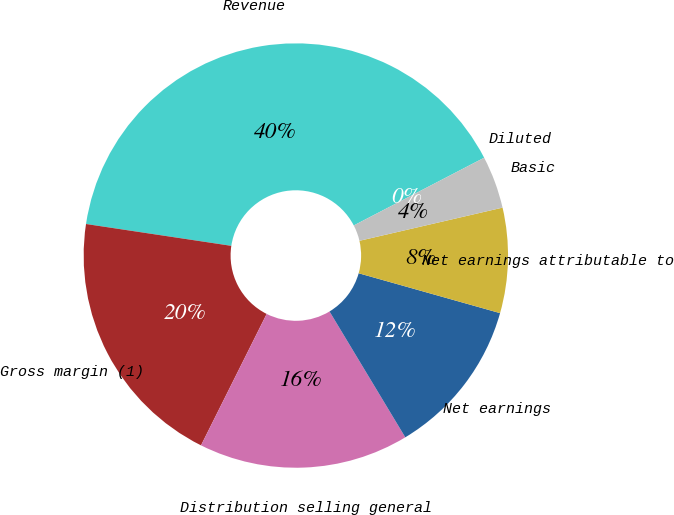Convert chart to OTSL. <chart><loc_0><loc_0><loc_500><loc_500><pie_chart><fcel>Revenue<fcel>Gross margin (1)<fcel>Distribution selling general<fcel>Net earnings<fcel>Net earnings attributable to<fcel>Basic<fcel>Diluted<nl><fcel>40.0%<fcel>20.0%<fcel>16.0%<fcel>12.0%<fcel>8.0%<fcel>4.0%<fcel>0.0%<nl></chart> 